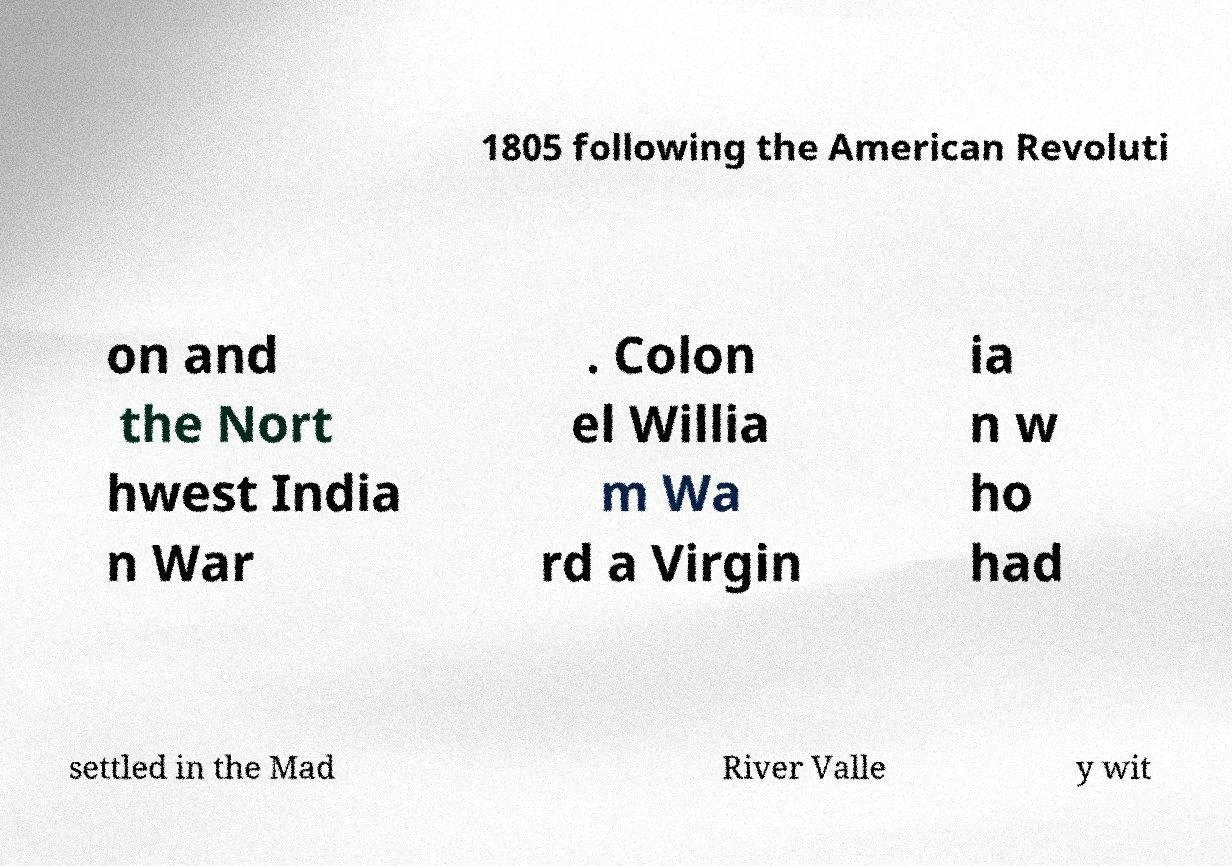I need the written content from this picture converted into text. Can you do that? 1805 following the American Revoluti on and the Nort hwest India n War . Colon el Willia m Wa rd a Virgin ia n w ho had settled in the Mad River Valle y wit 